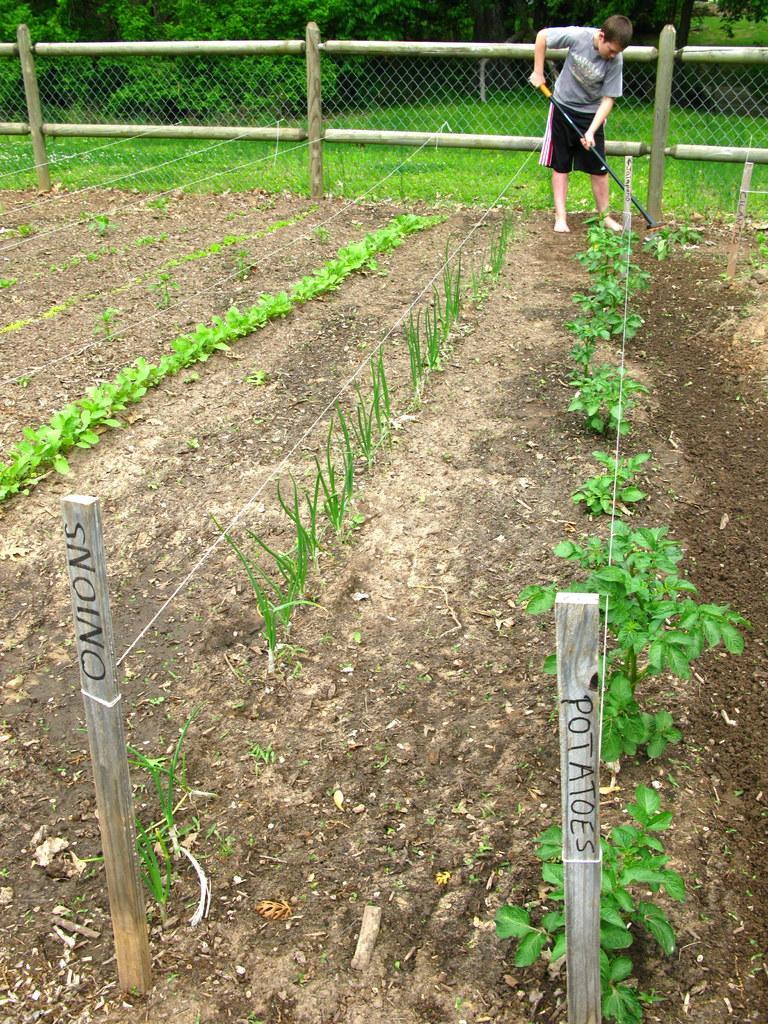How would you summarize this image in a sentence or two? In this image, I can see the plants. Here is a person standing and holding an object. I can see the ropes tied to the wooden pillars. This looks like a fence. In the background, I can see the trees and the grass. 